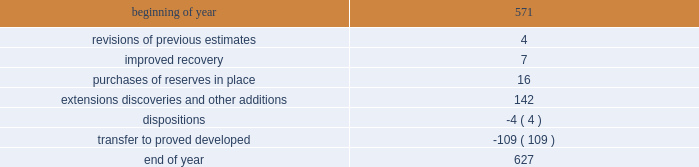Changes in proved undeveloped reserves as of december 31 , 2013 , 627 mmboe of proved undeveloped reserves were reported , an increase of 56 mmboe from december 31 , 2012 .
The table shows changes in total proved undeveloped reserves for 2013 : ( mmboe ) .
Significant additions to proved undeveloped reserves during 2013 included 72 mmboe in the eagle ford and 49 mmboe in the bakken shale plays due to development drilling .
Transfers from proved undeveloped to proved developed reserves included 57 mmboe in the eagle ford , 18 mmboe in the bakken and 7 mmboe in the oklahoma resource basins due to producing wells .
Costs incurred in 2013 , 2012 and 2011 relating to the development of proved undeveloped reserves , were $ 2536 million , $ 1995 million and $ 1107 million .
A total of 59 mmboe was booked as a result of reliable technology .
Technologies included statistical analysis of production performance , decline curve analysis , rate transient analysis , reservoir simulation and volumetric analysis .
The statistical nature of production performance coupled with highly certain reservoir continuity or quality within the reliable technology areas and sufficient proved undeveloped locations establish the reasonable certainty criteria required for booking reserves .
Projects can remain in proved undeveloped reserves for extended periods in certain situations such as large development projects which take more than five years to complete , or the timing of when additional gas compression is needed .
Of the 627 mmboe of proved undeveloped reserves at december 31 , 2013 , 24 percent of the volume is associated with projects that have been included in proved reserves for more than five years .
The majority of this volume is related to a compression project in e.g .
That was sanctioned by our board of directors in 2004 .
The timing of the installation of compression is being driven by the reservoir performance with this project intended to maintain maximum production levels .
Performance of this field since the board sanctioned the project has far exceeded expectations .
Estimates of initial dry gas in place increased by roughly 10 percent between 2004 and 2010 .
During 2012 , the compression project received the approval of the e.g .
Government , allowing design and planning work to progress towards implementation , with completion expected by mid-2016 .
The other component of alba proved undeveloped reserves is an infill well approved in 2013 and to be drilled late 2014 .
Proved undeveloped reserves for the north gialo development , located in the libyan sahara desert , were booked for the first time as proved undeveloped reserves in 2010 .
This development , which is anticipated to take more than five years to be developed , is being executed by the operator and encompasses a continuous drilling program including the design , fabrication and installation of extensive liquid handling and gas recycling facilities .
Anecdotal evidence from similar development projects in the region led to an expected project execution of more than five years from the time the reserves were initially booked .
Interruptions associated with the civil unrest in 2011 and third-party labor strikes in 2013 have extended the project duration .
There are no other significant undeveloped reserves expected to be developed more than five years after their original booking .
As of december 31 , 2013 , future development costs estimated to be required for the development of proved undeveloped liquid hydrocarbon , natural gas and synthetic crude oil reserves related to continuing operations for the years 2014 through 2018 are projected to be $ 2894 million , $ 2567 million , $ 2020 million , $ 1452 million and $ 575 million .
The timing of future projects and estimated future development costs relating to the development of proved undeveloped liquid hydrocarbon , natural gas and synthetic crude oil reserves are forward-looking statements and are based on a number of assumptions , including ( among others ) commodity prices , presently known physical data concerning size and character of the reservoirs , economic recoverability , technology developments , future drilling success , industry economic conditions , levels of cash flow from operations , production experience and other operating considerations .
To the extent these assumptions prove inaccurate , actual recoveries , timing and development costs could be different than current estimates. .
Were significant additions to proved undeveloped reserves during 2013 in the eagle ford greater than the bakken? 
Computations: (72 > 49)
Answer: yes. 